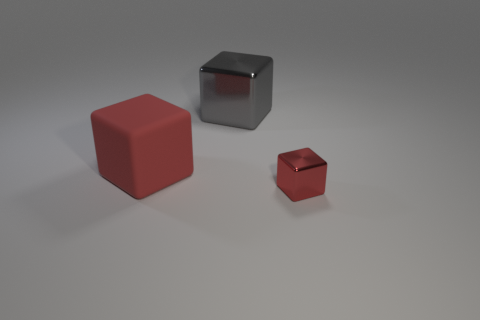Is there anything in the image that provides a sense of scale? There is no direct reference object in the image to accurately determine the scale of the cubes, leaving their actual size open to interpretation. 